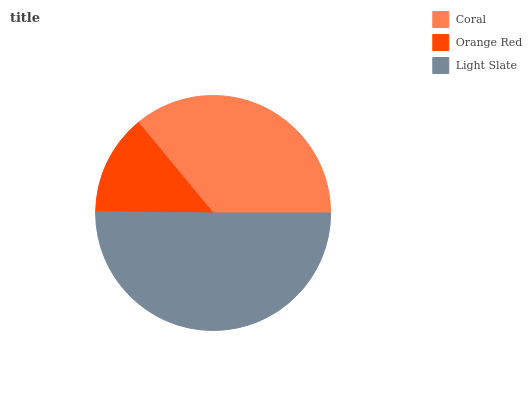Is Orange Red the minimum?
Answer yes or no. Yes. Is Light Slate the maximum?
Answer yes or no. Yes. Is Light Slate the minimum?
Answer yes or no. No. Is Orange Red the maximum?
Answer yes or no. No. Is Light Slate greater than Orange Red?
Answer yes or no. Yes. Is Orange Red less than Light Slate?
Answer yes or no. Yes. Is Orange Red greater than Light Slate?
Answer yes or no. No. Is Light Slate less than Orange Red?
Answer yes or no. No. Is Coral the high median?
Answer yes or no. Yes. Is Coral the low median?
Answer yes or no. Yes. Is Orange Red the high median?
Answer yes or no. No. Is Light Slate the low median?
Answer yes or no. No. 